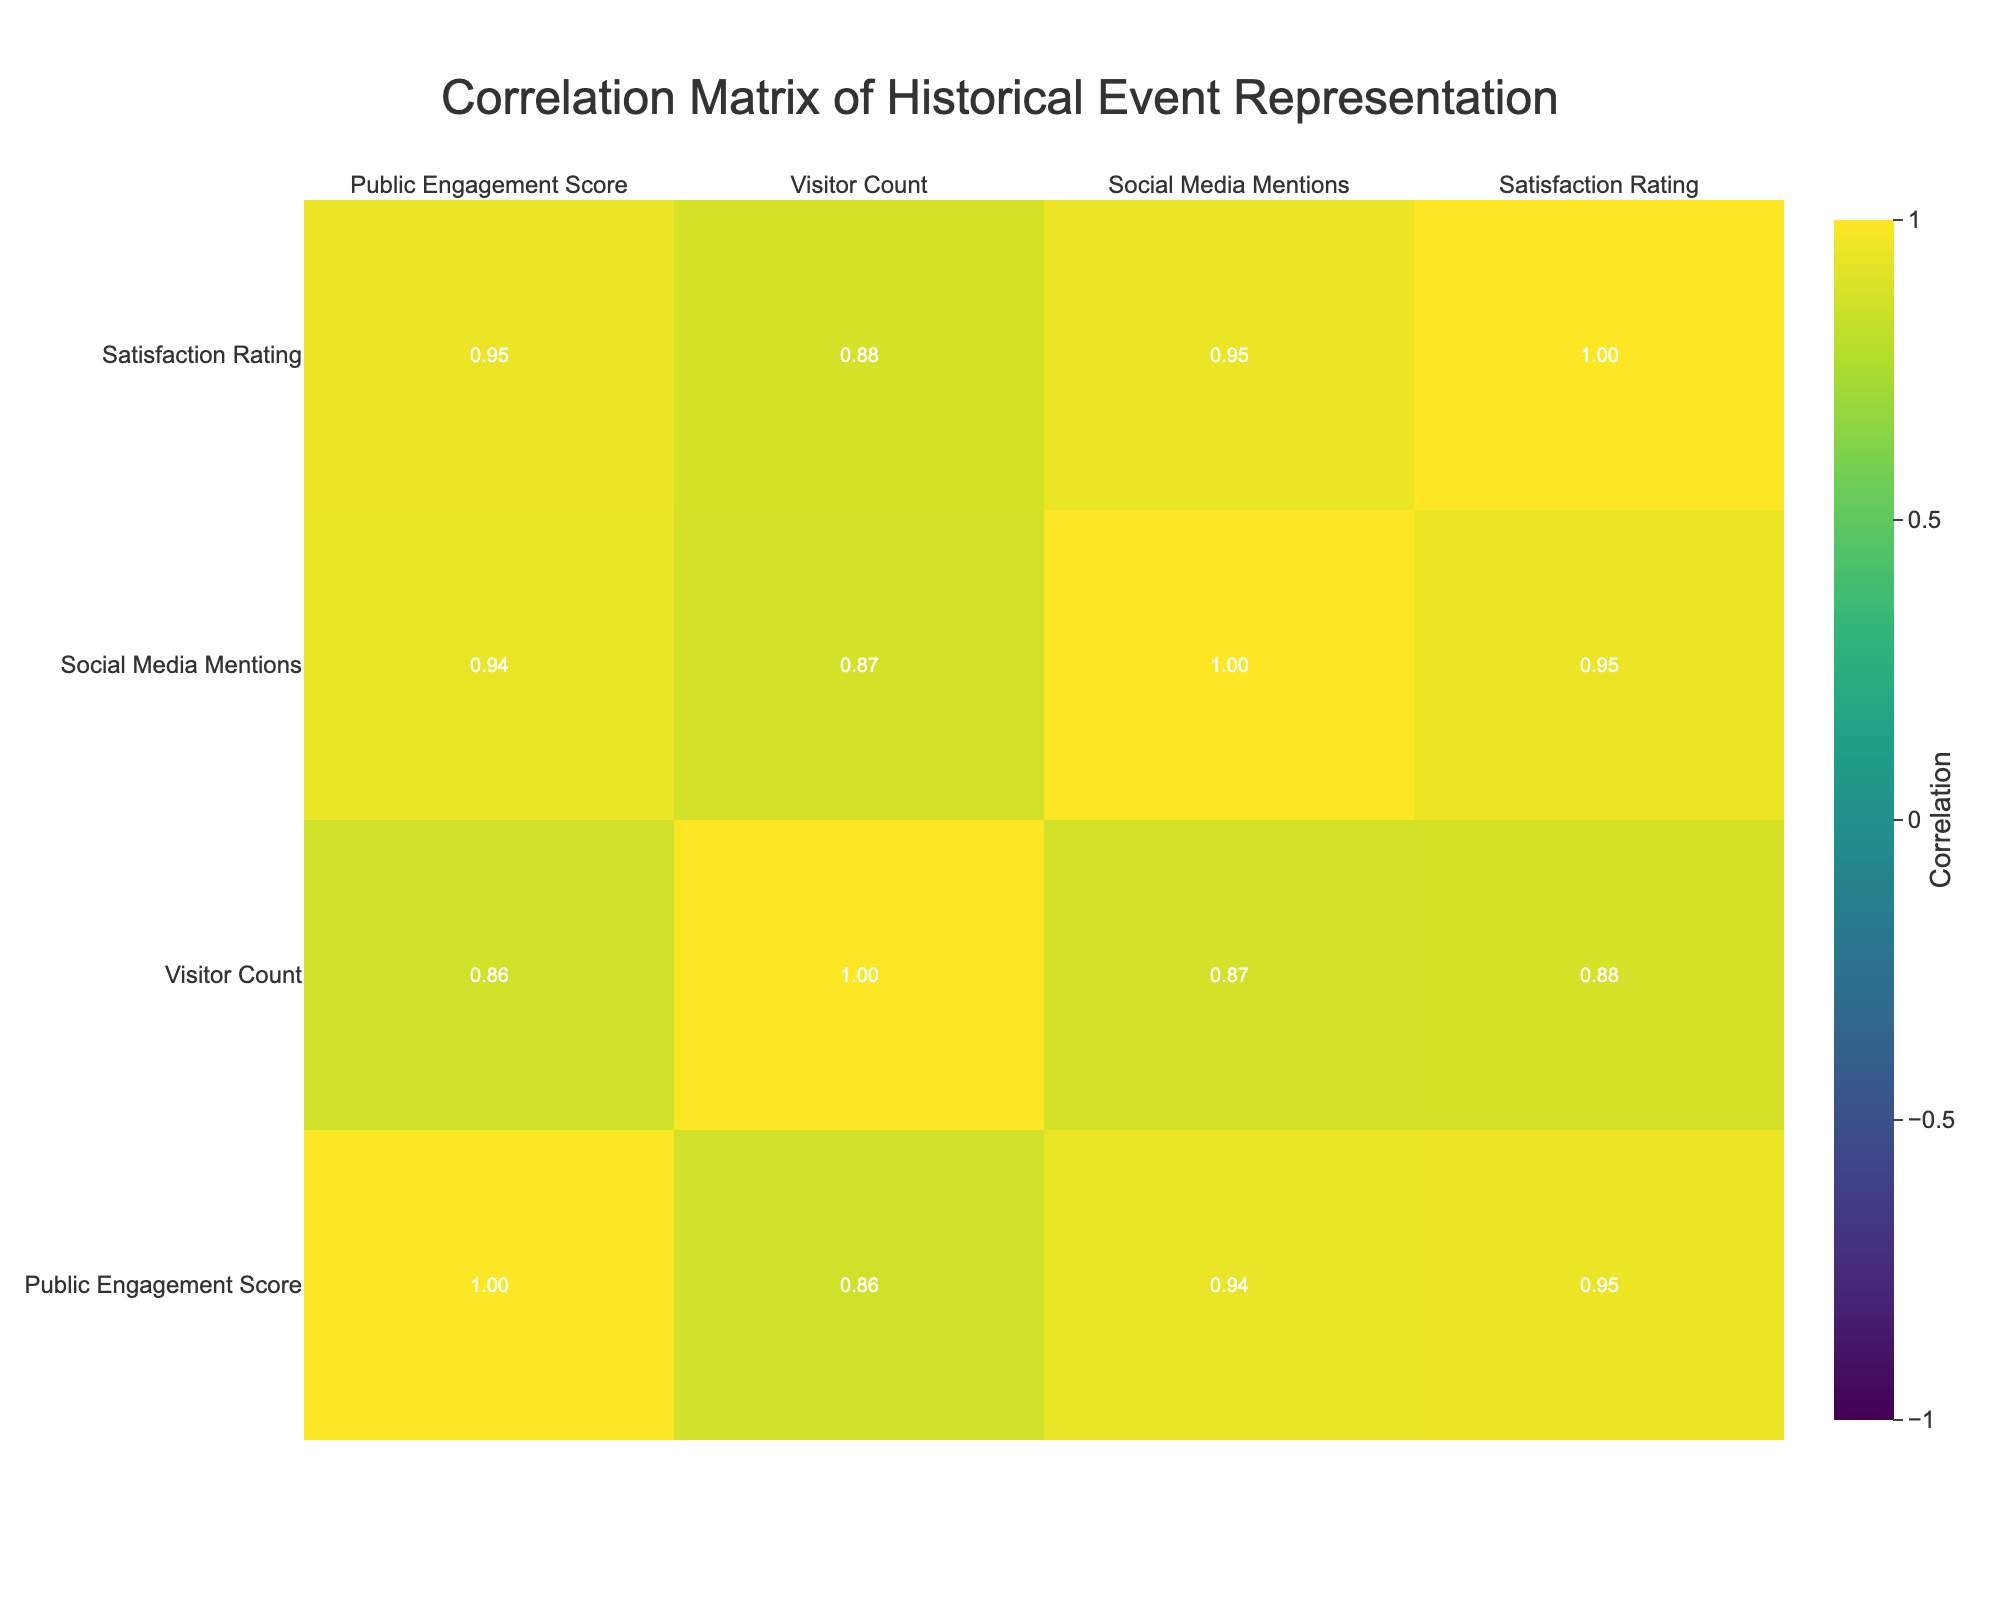What is the public engagement score for the "Moon Landing" event? According to the table, the public engagement score for the "Moon Landing" event is listed directly in the row corresponding to that event, which shows a score of 76.
Answer: 76 What representation style is associated with the "Women’s Suffrage Movement"? The table indicates the representation style in the row for the "Women’s Suffrage Movement", which is labeled as a "Memorial Sculpture".
Answer: Memorial Sculpture Does the "Fall of the Berlin Wall" have a higher public engagement score than the "Industrial Revolution"? To answer this, compare the public engagement score for both events: the "Fall of the Berlin Wall" has a score of 92 and the "Industrial Revolution" has a score of 75. Since 92 is greater than 75, the answer is yes.
Answer: Yes What is the average visitor count for the events represented in the table? First, sum the visitor counts from all the events: 12000 + 15000 + 18000 + 14000 + 9000 + 12500 + 11000 + 7000 + 16000 + 13500 = 128000. Then, divide by the total number of events, which is 10: 128000 / 10 = 12800.
Answer: 12800 Are there more social media mentions for the "Signing of the Declaration of Independence" compared to the "Discovery of Penicillin"? The table shows that the "Signing of the Declaration of Independence" received 1500 social media mentions, while "Discovery of Penicillin" received 500. Since 1500 is greater than 500, the answer is yes.
Answer: Yes Which event has the highest satisfaction rating, and what is that rating? Review all satisfaction ratings in the table to find the highest value. The "Fall of the Berlin Wall" has the highest rating at 4.9.
Answer: 4.9 What is the difference in public engagement scores between the "Martin Luther King Jr.'s 'I Have a Dream' Speech" and the "Construction of the Great Wall of China"? The public engagement score for the "Martin Luther King Jr.'s 'I Have a Dream' Speech" is 84, while for the "Construction of the Great Wall of China" it is 70. The difference is 84 - 70 = 14.
Answer: 14 Which event with a representation style listed as an installation has the highest satisfaction rating? The two events with installation styles are the "Martin Luther King Jr.'s 'I Have a Dream' Speech" (4.7) and "Fall of the Berlin Wall" (4.9). Comparing these satisfaction ratings, "Fall of the Berlin Wall" has the highest at 4.9.
Answer: Fall of the Berlin Wall 